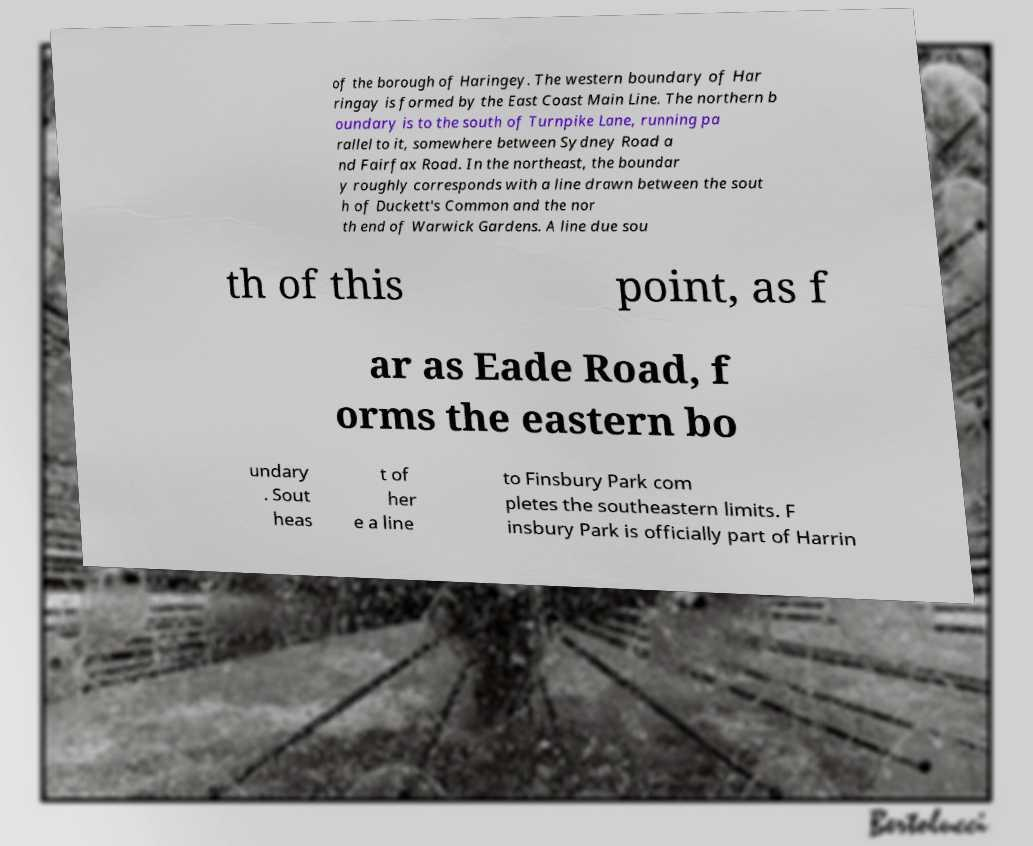Please identify and transcribe the text found in this image. of the borough of Haringey. The western boundary of Har ringay is formed by the East Coast Main Line. The northern b oundary is to the south of Turnpike Lane, running pa rallel to it, somewhere between Sydney Road a nd Fairfax Road. In the northeast, the boundar y roughly corresponds with a line drawn between the sout h of Duckett's Common and the nor th end of Warwick Gardens. A line due sou th of this point, as f ar as Eade Road, f orms the eastern bo undary . Sout heas t of her e a line to Finsbury Park com pletes the southeastern limits. F insbury Park is officially part of Harrin 